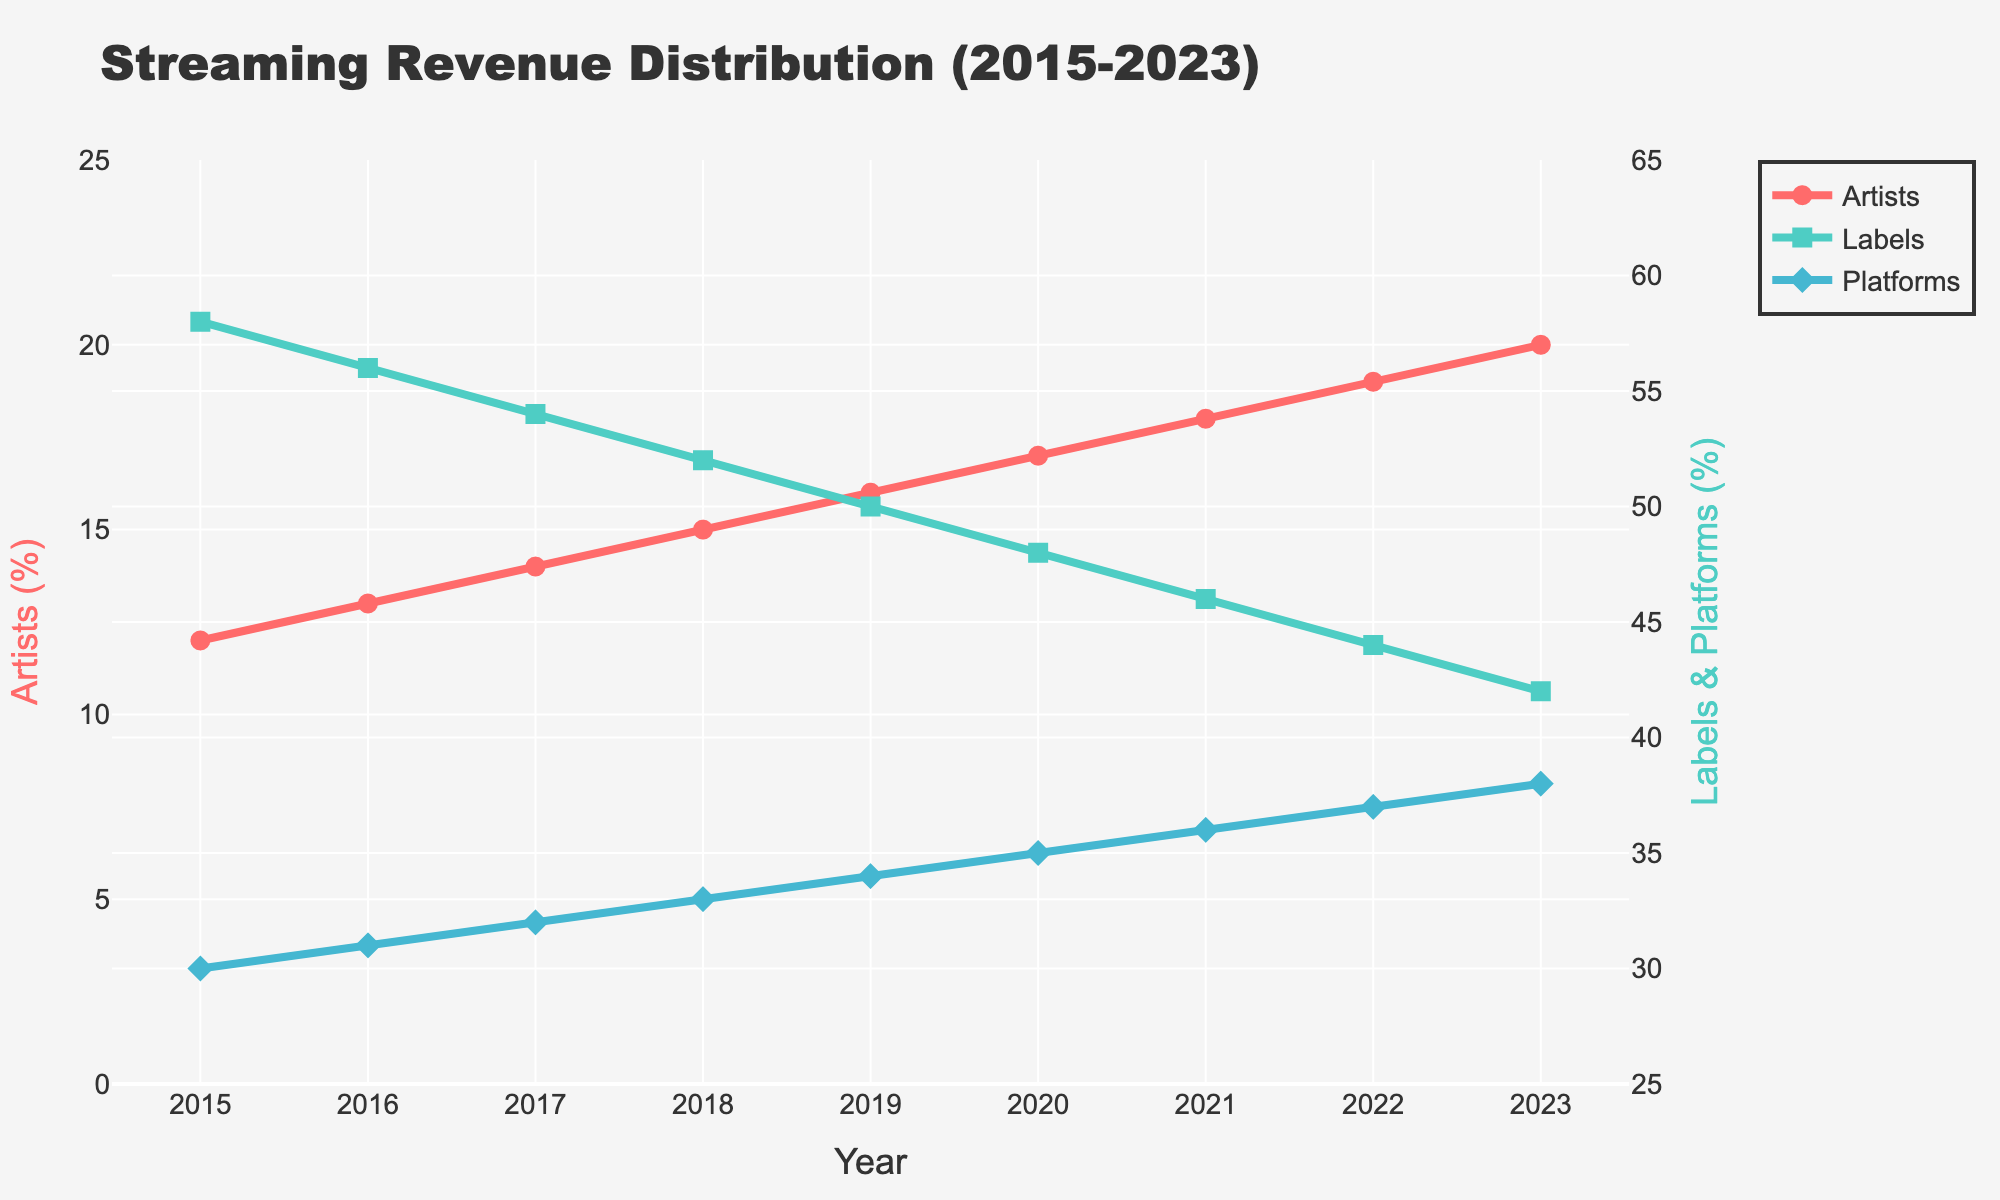what is the percentage of revenue distribution for artists in 2018? To find the distribution percentage for artists in 2018, look at the "Artists" line and locate the value on the y-axis that corresponds to the year 2018.
Answer: 15% how did the revenue distribution change for labels from 2015 to 2023? To determine the change in revenue distribution for labels from 2015 to 2023, subtract the 2023 percentage from the 2015 percentage.
Answer: Decreased by 16% which group saw the highest percentage increase in revenue distribution from 2015 to 2023? Observe the lines representing each group and calculate the percentage increase. Artists increased from 12% to 20%, Labels decreased from 58% to 42%, and Platforms increased from 30% to 38%. The highest increase is for artists.
Answer: Artists how does the revenue distribution for platforms in 2021 compare to that in 2015? Look at the y-axis values for the "Platforms" line at the years 2021 and 2015. In 2021, platforms have 36%, and in 2015, they have 30%.
Answer: Increased by 6% if the trend continues, what would be the expected percentage revenue distribution for artists in 2024? The increase from year to year for artists appears to be 1%. Hence, adding 1% to the value in 2023 (20%) gives an expectation for 2024.
Answer: 21% between which consecutive years did artists see the smallest increase in revenue distribution? Calculate the year-over-year increase for artists and identify the smallest change. Between 2016 and 2017, the increase was from 13% to 14%, the smallest annual increase (1%).
Answer: 2016-2017 how did the revenue distribution for platforms change every year from 2015 to 2023? The "Platforms" percentage needs to be observed for each year, showing yearly increments. (30% → 31% → 32% → 33% → 34% → 35% → 36% → 37% → 38%).
Answer: Increased by 1% each year which group had a decreasing trend in revenue distribution over the years, and by how much did it decrease? By examining the trends, labels showed a decreasing trend from 58% to 42%, a decrease of 16%.
Answer: Labels, by 16% 